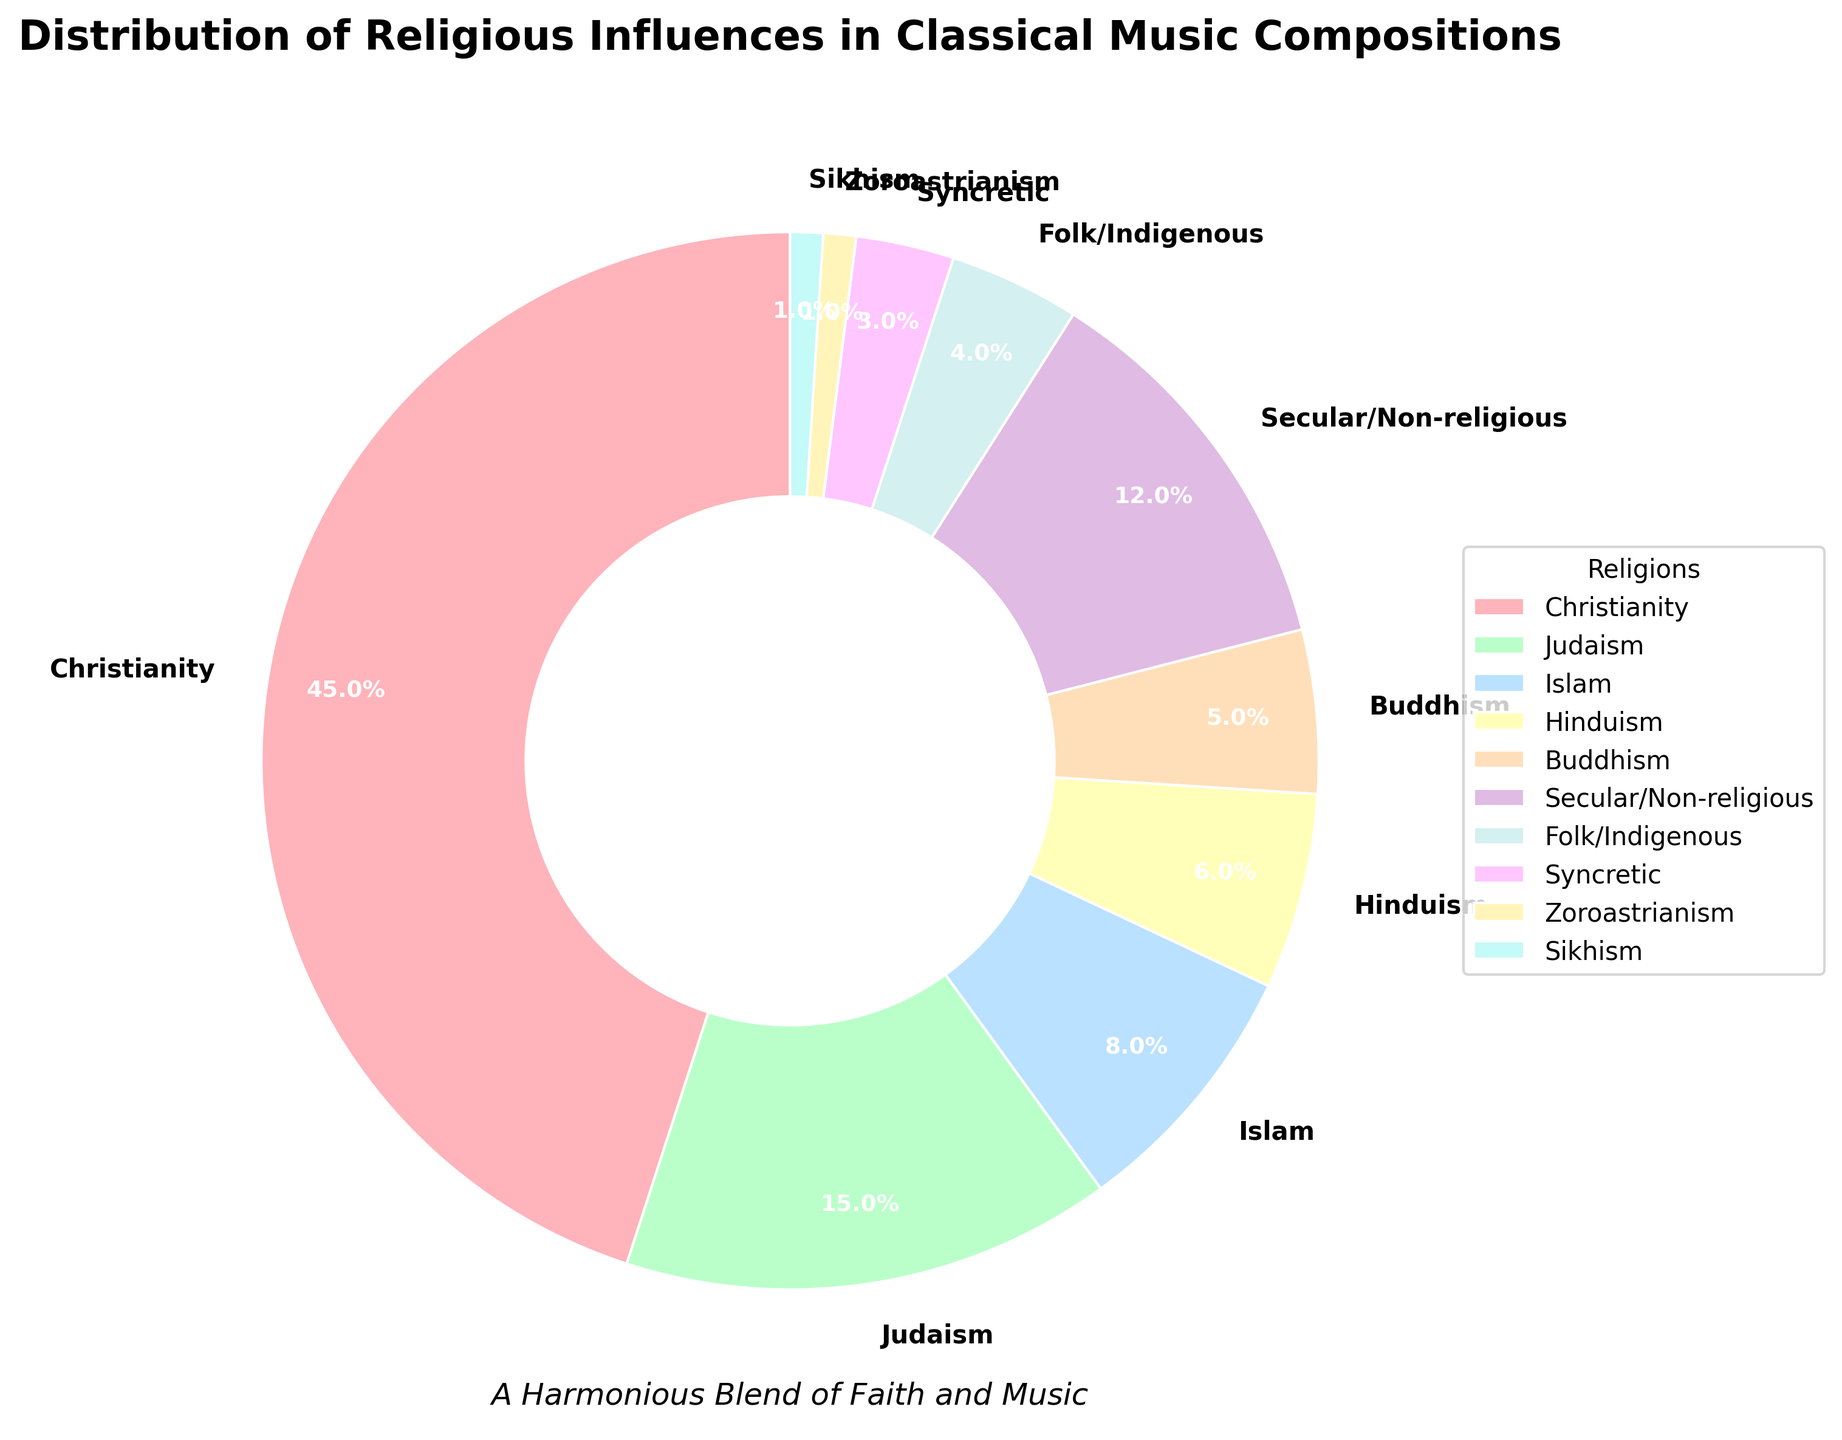What's the total percentage of compositions influenced by Christianity, Judaism, and Islam combined? To find the total percentage, add the percentages for Christianity (45%), Judaism (15%), and Islam (8%). 45 + 15 + 8 = 68.
Answer: 68% Which influence is depicted with the most prominent section in the pie chart? The most prominent section in the pie chart represents the largest percentage. The section for Christianity is the largest at 45%.
Answer: Christianity How does the influence of Secular/Non-religious compositions compare to that of Folk/Indigenous compositions? The pie chart shows the percentages for Secular/Non-religious (12%) and Folk/Indigenous (4%). Secular/Non-religious compositions have a greater influence than Folk/Indigenous compositions because 12% is larger than 4%.
Answer: Secular/Non-religious is greater What is the difference in influence percentage between Buddhism and Hinduism? To find the difference, subtract the percentage for Buddhism (5%) from Hinduism (6%). 6 - 5 = 1.
Answer: 1% What is the average percentage of all the religious influences excluding Secular/Non-religious? First, sum the percentages of all religious influences excluding Secular/Non-religious: Christianity (45%), Judaism (15%), Islam (8%), Hinduism (6%), Buddhism (5%), Folk/Indigenous (4%), Syncretic (3%), Zoroastrianism (1%), Sikhism (1%). The sum is 45 + 15 + 8 + 6 + 5 + 4 + 3 + 1 + 1 = 88. Then divide by the number of influences excluding Secular/Non-religious, which is 9. 88 / 9 = 9.78.
Answer: 9.78% Which category appears to have the least influence and what percentage does it represent? The smallest section in the pie chart represents the smallest percentage. Both Zoroastrianism and Sikhism have the least influence at 1% each.
Answer: Zoroastrianism and Sikhism What is the combined influence of Buddhism, Folk/Indigenous, and Syncretic compositions? Add the percentages for Buddhism (5%), Folk/Indigenous (4%), and Syncretic (3%). 5 + 4 + 3 = 12.
Answer: 12% What is the percentage difference between Secular/Non-religious influences and the total of Islamic and Hindu compositions? First, calculate the total percentage of Islamic and Hindu compositions: Islam (8%) + Hinduism (6%) = 14%. Then, find the difference between Secular/Non-religious (12%) and this total: 14 - 12 = 2.
Answer: 2% What percentage of compositions is influenced by religions other than Christianity? Sum the percentages of all influences other than Christianity: Judaism (15%), Islam (8%), Hinduism (6%), Buddhism (5%), Secular/Non-religious (12%), Folk/Indigenous (4%), Syncretic (3%), Zoroastrianism (1%), and Sikhism (1%). The sum total is 15 + 8 + 6 + 5 + 12 + 4 + 3 + 1 + 1 = 55.
Answer: 55% 